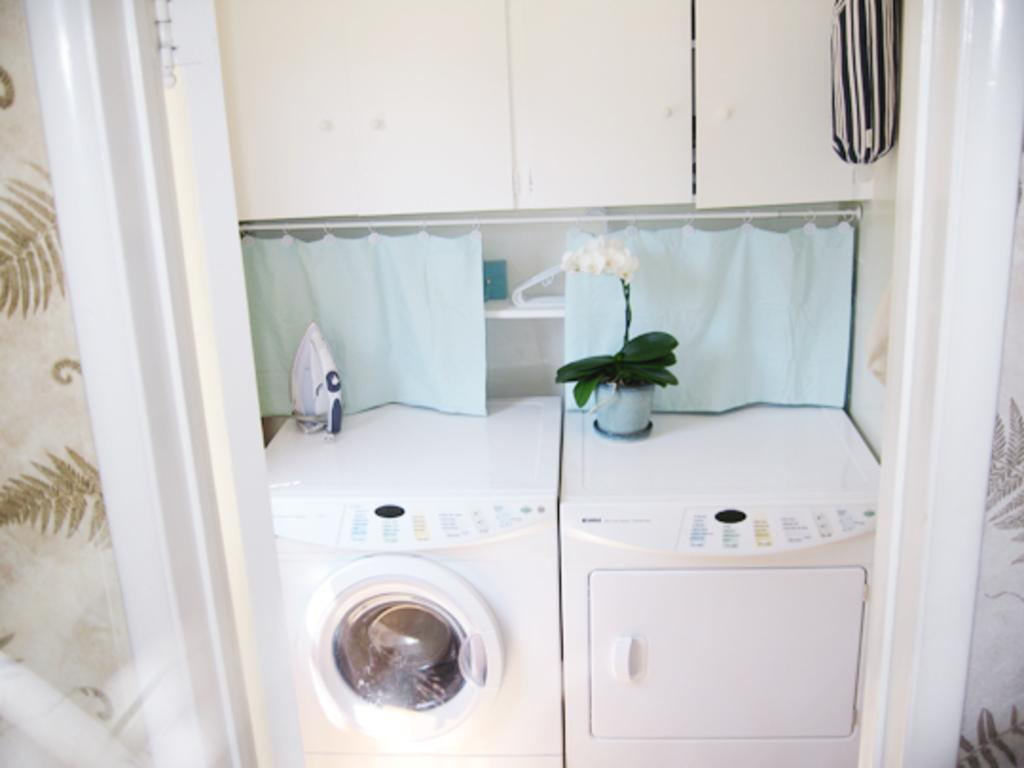What type of appliances can be seen in the image? There are washing machines in the image. What other household item is present in the image? There is an iron box in the image. What might be the purpose of the objects in the image? The objects in the image are likely used for cleaning and pressing clothes, as there are clothes present. What can be seen in the background of the image? There is a wall in the background of the image. What type of blood stain can be seen on the letter in the image? There is no letter or blood stain present in the image. How does the washing machine shake during its operation in the image? The washing machine does not shake during its operation in the image; it is stationary. 